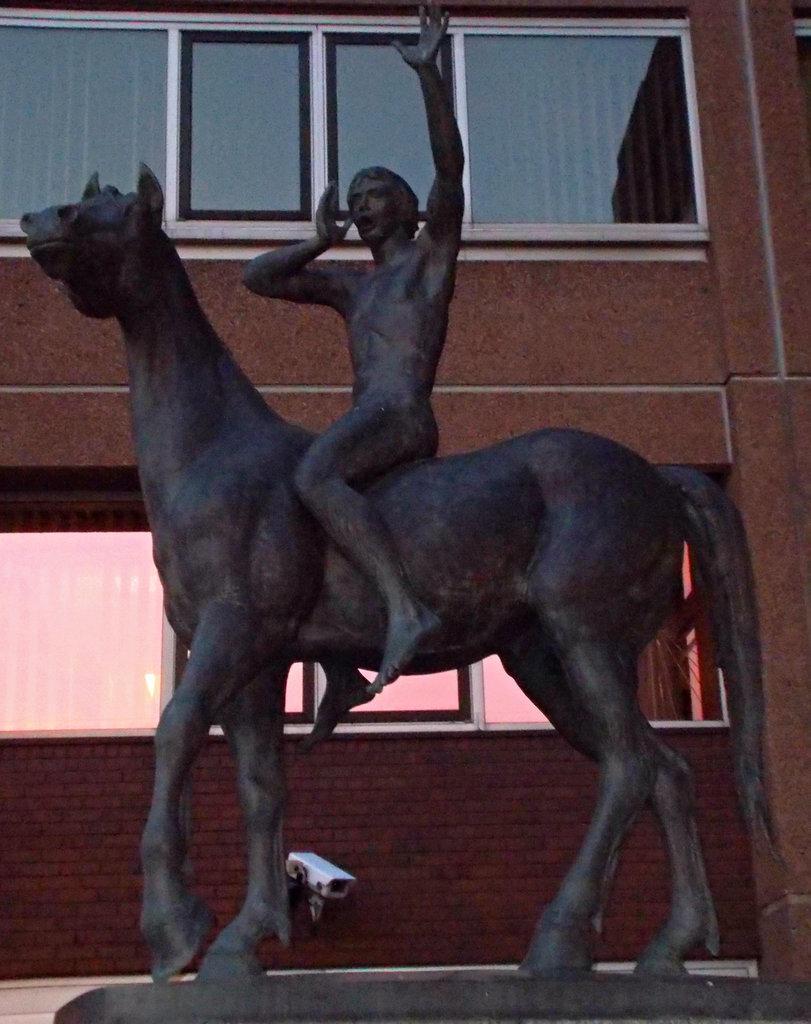Could you give a brief overview of what you see in this image? In this picture there is a statue of a man who is sitting on the horse and behind the statue there is a building. 